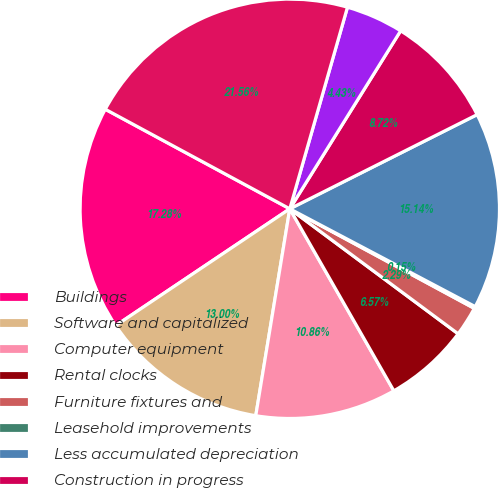Convert chart to OTSL. <chart><loc_0><loc_0><loc_500><loc_500><pie_chart><fcel>Buildings<fcel>Software and capitalized<fcel>Computer equipment<fcel>Rental clocks<fcel>Furniture fixtures and<fcel>Leasehold improvements<fcel>Less accumulated depreciation<fcel>Construction in progress<fcel>Land<fcel>Property and equipment net<nl><fcel>17.28%<fcel>13.0%<fcel>10.86%<fcel>6.57%<fcel>2.29%<fcel>0.15%<fcel>15.14%<fcel>8.72%<fcel>4.43%<fcel>21.56%<nl></chart> 